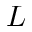Convert formula to latex. <formula><loc_0><loc_0><loc_500><loc_500>L</formula> 